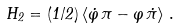Convert formula to latex. <formula><loc_0><loc_0><loc_500><loc_500>H _ { 2 } = ( 1 / 2 ) \left \langle \dot { \varphi } \, \pi - \varphi \, \dot { \pi } \right \rangle \, .</formula> 